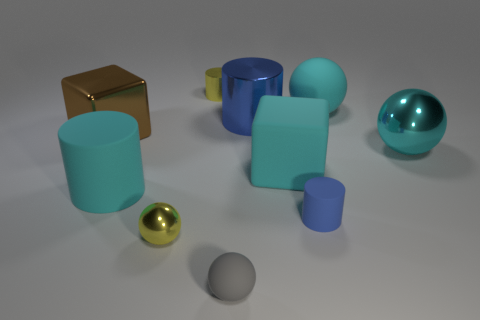Can you describe the lighting and shadows in the scene? The lighting in the scene is soft and diffused, suggesting an overcast sky or a single soft light source above the objects. Shadows are soft-edged and fall mostly to the right of the objects, indicating the light source is coming from the upper left. This creates a calm and evenly lit composition with no harsh contrasts. 